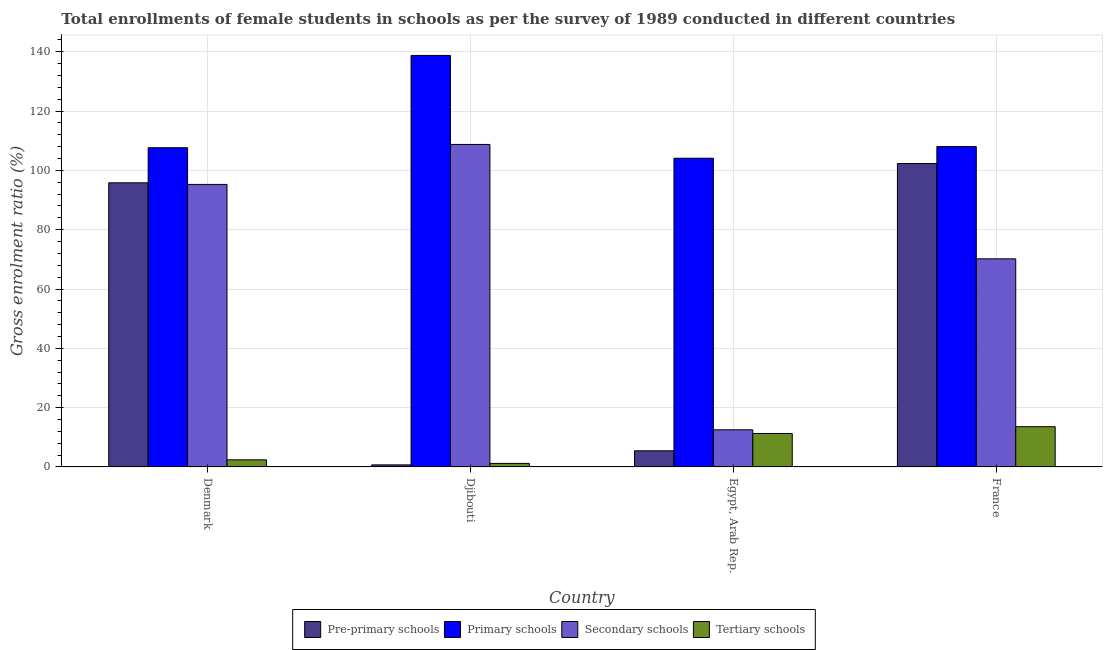Are the number of bars on each tick of the X-axis equal?
Provide a short and direct response. Yes. How many bars are there on the 2nd tick from the left?
Provide a succinct answer. 4. How many bars are there on the 1st tick from the right?
Your response must be concise. 4. What is the label of the 2nd group of bars from the left?
Offer a terse response. Djibouti. What is the gross enrolment ratio(female) in secondary schools in France?
Provide a short and direct response. 70.17. Across all countries, what is the maximum gross enrolment ratio(female) in primary schools?
Give a very brief answer. 138.76. Across all countries, what is the minimum gross enrolment ratio(female) in primary schools?
Keep it short and to the point. 104.1. In which country was the gross enrolment ratio(female) in primary schools maximum?
Your response must be concise. Djibouti. In which country was the gross enrolment ratio(female) in pre-primary schools minimum?
Provide a succinct answer. Djibouti. What is the total gross enrolment ratio(female) in secondary schools in the graph?
Give a very brief answer. 286.72. What is the difference between the gross enrolment ratio(female) in secondary schools in Egypt, Arab Rep. and that in France?
Provide a short and direct response. -57.65. What is the difference between the gross enrolment ratio(female) in tertiary schools in Egypt, Arab Rep. and the gross enrolment ratio(female) in secondary schools in France?
Provide a succinct answer. -58.89. What is the average gross enrolment ratio(female) in pre-primary schools per country?
Provide a short and direct response. 51.06. What is the difference between the gross enrolment ratio(female) in pre-primary schools and gross enrolment ratio(female) in secondary schools in France?
Provide a short and direct response. 32.14. In how many countries, is the gross enrolment ratio(female) in primary schools greater than 32 %?
Provide a succinct answer. 4. What is the ratio of the gross enrolment ratio(female) in primary schools in Denmark to that in Djibouti?
Give a very brief answer. 0.78. What is the difference between the highest and the second highest gross enrolment ratio(female) in pre-primary schools?
Keep it short and to the point. 6.5. What is the difference between the highest and the lowest gross enrolment ratio(female) in tertiary schools?
Your answer should be very brief. 12.38. In how many countries, is the gross enrolment ratio(female) in tertiary schools greater than the average gross enrolment ratio(female) in tertiary schools taken over all countries?
Provide a succinct answer. 2. What does the 1st bar from the left in France represents?
Your answer should be very brief. Pre-primary schools. What does the 1st bar from the right in France represents?
Your response must be concise. Tertiary schools. How many bars are there?
Offer a terse response. 16. Are all the bars in the graph horizontal?
Provide a short and direct response. No. How many countries are there in the graph?
Keep it short and to the point. 4. Are the values on the major ticks of Y-axis written in scientific E-notation?
Give a very brief answer. No. How are the legend labels stacked?
Offer a terse response. Horizontal. What is the title of the graph?
Your response must be concise. Total enrollments of female students in schools as per the survey of 1989 conducted in different countries. Does "Salary of employees" appear as one of the legend labels in the graph?
Offer a terse response. No. What is the label or title of the X-axis?
Ensure brevity in your answer.  Country. What is the label or title of the Y-axis?
Provide a short and direct response. Gross enrolment ratio (%). What is the Gross enrolment ratio (%) of Pre-primary schools in Denmark?
Offer a terse response. 95.81. What is the Gross enrolment ratio (%) in Primary schools in Denmark?
Give a very brief answer. 107.64. What is the Gross enrolment ratio (%) in Secondary schools in Denmark?
Your answer should be very brief. 95.27. What is the Gross enrolment ratio (%) in Tertiary schools in Denmark?
Your response must be concise. 2.39. What is the Gross enrolment ratio (%) in Pre-primary schools in Djibouti?
Provide a succinct answer. 0.69. What is the Gross enrolment ratio (%) of Primary schools in Djibouti?
Provide a short and direct response. 138.76. What is the Gross enrolment ratio (%) of Secondary schools in Djibouti?
Your answer should be compact. 108.75. What is the Gross enrolment ratio (%) of Tertiary schools in Djibouti?
Ensure brevity in your answer.  1.19. What is the Gross enrolment ratio (%) in Pre-primary schools in Egypt, Arab Rep.?
Offer a very short reply. 5.44. What is the Gross enrolment ratio (%) of Primary schools in Egypt, Arab Rep.?
Offer a terse response. 104.1. What is the Gross enrolment ratio (%) of Secondary schools in Egypt, Arab Rep.?
Your answer should be very brief. 12.52. What is the Gross enrolment ratio (%) in Tertiary schools in Egypt, Arab Rep.?
Offer a terse response. 11.28. What is the Gross enrolment ratio (%) of Pre-primary schools in France?
Offer a very short reply. 102.31. What is the Gross enrolment ratio (%) in Primary schools in France?
Make the answer very short. 108.03. What is the Gross enrolment ratio (%) of Secondary schools in France?
Your answer should be very brief. 70.17. What is the Gross enrolment ratio (%) in Tertiary schools in France?
Give a very brief answer. 13.57. Across all countries, what is the maximum Gross enrolment ratio (%) of Pre-primary schools?
Provide a short and direct response. 102.31. Across all countries, what is the maximum Gross enrolment ratio (%) in Primary schools?
Make the answer very short. 138.76. Across all countries, what is the maximum Gross enrolment ratio (%) of Secondary schools?
Provide a succinct answer. 108.75. Across all countries, what is the maximum Gross enrolment ratio (%) of Tertiary schools?
Offer a very short reply. 13.57. Across all countries, what is the minimum Gross enrolment ratio (%) in Pre-primary schools?
Your response must be concise. 0.69. Across all countries, what is the minimum Gross enrolment ratio (%) of Primary schools?
Provide a short and direct response. 104.1. Across all countries, what is the minimum Gross enrolment ratio (%) of Secondary schools?
Your response must be concise. 12.52. Across all countries, what is the minimum Gross enrolment ratio (%) in Tertiary schools?
Provide a short and direct response. 1.19. What is the total Gross enrolment ratio (%) in Pre-primary schools in the graph?
Make the answer very short. 204.26. What is the total Gross enrolment ratio (%) of Primary schools in the graph?
Offer a very short reply. 458.53. What is the total Gross enrolment ratio (%) in Secondary schools in the graph?
Your response must be concise. 286.72. What is the total Gross enrolment ratio (%) of Tertiary schools in the graph?
Ensure brevity in your answer.  28.44. What is the difference between the Gross enrolment ratio (%) in Pre-primary schools in Denmark and that in Djibouti?
Provide a succinct answer. 95.12. What is the difference between the Gross enrolment ratio (%) in Primary schools in Denmark and that in Djibouti?
Ensure brevity in your answer.  -31.12. What is the difference between the Gross enrolment ratio (%) of Secondary schools in Denmark and that in Djibouti?
Offer a terse response. -13.48. What is the difference between the Gross enrolment ratio (%) in Tertiary schools in Denmark and that in Djibouti?
Give a very brief answer. 1.2. What is the difference between the Gross enrolment ratio (%) of Pre-primary schools in Denmark and that in Egypt, Arab Rep.?
Keep it short and to the point. 90.37. What is the difference between the Gross enrolment ratio (%) of Primary schools in Denmark and that in Egypt, Arab Rep.?
Keep it short and to the point. 3.54. What is the difference between the Gross enrolment ratio (%) of Secondary schools in Denmark and that in Egypt, Arab Rep.?
Offer a very short reply. 82.75. What is the difference between the Gross enrolment ratio (%) of Tertiary schools in Denmark and that in Egypt, Arab Rep.?
Ensure brevity in your answer.  -8.89. What is the difference between the Gross enrolment ratio (%) in Pre-primary schools in Denmark and that in France?
Keep it short and to the point. -6.5. What is the difference between the Gross enrolment ratio (%) in Primary schools in Denmark and that in France?
Offer a terse response. -0.39. What is the difference between the Gross enrolment ratio (%) in Secondary schools in Denmark and that in France?
Make the answer very short. 25.1. What is the difference between the Gross enrolment ratio (%) of Tertiary schools in Denmark and that in France?
Offer a very short reply. -11.18. What is the difference between the Gross enrolment ratio (%) in Pre-primary schools in Djibouti and that in Egypt, Arab Rep.?
Ensure brevity in your answer.  -4.75. What is the difference between the Gross enrolment ratio (%) of Primary schools in Djibouti and that in Egypt, Arab Rep.?
Give a very brief answer. 34.66. What is the difference between the Gross enrolment ratio (%) in Secondary schools in Djibouti and that in Egypt, Arab Rep.?
Make the answer very short. 96.23. What is the difference between the Gross enrolment ratio (%) in Tertiary schools in Djibouti and that in Egypt, Arab Rep.?
Provide a succinct answer. -10.09. What is the difference between the Gross enrolment ratio (%) of Pre-primary schools in Djibouti and that in France?
Make the answer very short. -101.62. What is the difference between the Gross enrolment ratio (%) in Primary schools in Djibouti and that in France?
Your answer should be very brief. 30.73. What is the difference between the Gross enrolment ratio (%) of Secondary schools in Djibouti and that in France?
Your answer should be compact. 38.58. What is the difference between the Gross enrolment ratio (%) in Tertiary schools in Djibouti and that in France?
Ensure brevity in your answer.  -12.38. What is the difference between the Gross enrolment ratio (%) of Pre-primary schools in Egypt, Arab Rep. and that in France?
Offer a very short reply. -96.87. What is the difference between the Gross enrolment ratio (%) of Primary schools in Egypt, Arab Rep. and that in France?
Give a very brief answer. -3.93. What is the difference between the Gross enrolment ratio (%) of Secondary schools in Egypt, Arab Rep. and that in France?
Keep it short and to the point. -57.65. What is the difference between the Gross enrolment ratio (%) in Tertiary schools in Egypt, Arab Rep. and that in France?
Your response must be concise. -2.29. What is the difference between the Gross enrolment ratio (%) of Pre-primary schools in Denmark and the Gross enrolment ratio (%) of Primary schools in Djibouti?
Your answer should be compact. -42.95. What is the difference between the Gross enrolment ratio (%) in Pre-primary schools in Denmark and the Gross enrolment ratio (%) in Secondary schools in Djibouti?
Provide a succinct answer. -12.94. What is the difference between the Gross enrolment ratio (%) of Pre-primary schools in Denmark and the Gross enrolment ratio (%) of Tertiary schools in Djibouti?
Offer a very short reply. 94.62. What is the difference between the Gross enrolment ratio (%) in Primary schools in Denmark and the Gross enrolment ratio (%) in Secondary schools in Djibouti?
Offer a terse response. -1.11. What is the difference between the Gross enrolment ratio (%) in Primary schools in Denmark and the Gross enrolment ratio (%) in Tertiary schools in Djibouti?
Your answer should be compact. 106.45. What is the difference between the Gross enrolment ratio (%) of Secondary schools in Denmark and the Gross enrolment ratio (%) of Tertiary schools in Djibouti?
Offer a terse response. 94.08. What is the difference between the Gross enrolment ratio (%) of Pre-primary schools in Denmark and the Gross enrolment ratio (%) of Primary schools in Egypt, Arab Rep.?
Provide a short and direct response. -8.29. What is the difference between the Gross enrolment ratio (%) of Pre-primary schools in Denmark and the Gross enrolment ratio (%) of Secondary schools in Egypt, Arab Rep.?
Provide a succinct answer. 83.29. What is the difference between the Gross enrolment ratio (%) in Pre-primary schools in Denmark and the Gross enrolment ratio (%) in Tertiary schools in Egypt, Arab Rep.?
Make the answer very short. 84.53. What is the difference between the Gross enrolment ratio (%) in Primary schools in Denmark and the Gross enrolment ratio (%) in Secondary schools in Egypt, Arab Rep.?
Your response must be concise. 95.12. What is the difference between the Gross enrolment ratio (%) of Primary schools in Denmark and the Gross enrolment ratio (%) of Tertiary schools in Egypt, Arab Rep.?
Provide a succinct answer. 96.36. What is the difference between the Gross enrolment ratio (%) of Secondary schools in Denmark and the Gross enrolment ratio (%) of Tertiary schools in Egypt, Arab Rep.?
Offer a terse response. 83.99. What is the difference between the Gross enrolment ratio (%) in Pre-primary schools in Denmark and the Gross enrolment ratio (%) in Primary schools in France?
Your response must be concise. -12.22. What is the difference between the Gross enrolment ratio (%) in Pre-primary schools in Denmark and the Gross enrolment ratio (%) in Secondary schools in France?
Your answer should be compact. 25.64. What is the difference between the Gross enrolment ratio (%) in Pre-primary schools in Denmark and the Gross enrolment ratio (%) in Tertiary schools in France?
Give a very brief answer. 82.24. What is the difference between the Gross enrolment ratio (%) of Primary schools in Denmark and the Gross enrolment ratio (%) of Secondary schools in France?
Make the answer very short. 37.47. What is the difference between the Gross enrolment ratio (%) in Primary schools in Denmark and the Gross enrolment ratio (%) in Tertiary schools in France?
Offer a very short reply. 94.07. What is the difference between the Gross enrolment ratio (%) of Secondary schools in Denmark and the Gross enrolment ratio (%) of Tertiary schools in France?
Ensure brevity in your answer.  81.7. What is the difference between the Gross enrolment ratio (%) in Pre-primary schools in Djibouti and the Gross enrolment ratio (%) in Primary schools in Egypt, Arab Rep.?
Make the answer very short. -103.41. What is the difference between the Gross enrolment ratio (%) of Pre-primary schools in Djibouti and the Gross enrolment ratio (%) of Secondary schools in Egypt, Arab Rep.?
Make the answer very short. -11.83. What is the difference between the Gross enrolment ratio (%) of Pre-primary schools in Djibouti and the Gross enrolment ratio (%) of Tertiary schools in Egypt, Arab Rep.?
Make the answer very short. -10.59. What is the difference between the Gross enrolment ratio (%) in Primary schools in Djibouti and the Gross enrolment ratio (%) in Secondary schools in Egypt, Arab Rep.?
Ensure brevity in your answer.  126.24. What is the difference between the Gross enrolment ratio (%) of Primary schools in Djibouti and the Gross enrolment ratio (%) of Tertiary schools in Egypt, Arab Rep.?
Provide a short and direct response. 127.48. What is the difference between the Gross enrolment ratio (%) in Secondary schools in Djibouti and the Gross enrolment ratio (%) in Tertiary schools in Egypt, Arab Rep.?
Offer a terse response. 97.47. What is the difference between the Gross enrolment ratio (%) of Pre-primary schools in Djibouti and the Gross enrolment ratio (%) of Primary schools in France?
Your answer should be compact. -107.34. What is the difference between the Gross enrolment ratio (%) of Pre-primary schools in Djibouti and the Gross enrolment ratio (%) of Secondary schools in France?
Offer a very short reply. -69.48. What is the difference between the Gross enrolment ratio (%) in Pre-primary schools in Djibouti and the Gross enrolment ratio (%) in Tertiary schools in France?
Ensure brevity in your answer.  -12.88. What is the difference between the Gross enrolment ratio (%) in Primary schools in Djibouti and the Gross enrolment ratio (%) in Secondary schools in France?
Your answer should be very brief. 68.59. What is the difference between the Gross enrolment ratio (%) of Primary schools in Djibouti and the Gross enrolment ratio (%) of Tertiary schools in France?
Keep it short and to the point. 125.19. What is the difference between the Gross enrolment ratio (%) of Secondary schools in Djibouti and the Gross enrolment ratio (%) of Tertiary schools in France?
Give a very brief answer. 95.18. What is the difference between the Gross enrolment ratio (%) of Pre-primary schools in Egypt, Arab Rep. and the Gross enrolment ratio (%) of Primary schools in France?
Ensure brevity in your answer.  -102.59. What is the difference between the Gross enrolment ratio (%) of Pre-primary schools in Egypt, Arab Rep. and the Gross enrolment ratio (%) of Secondary schools in France?
Make the answer very short. -64.73. What is the difference between the Gross enrolment ratio (%) in Pre-primary schools in Egypt, Arab Rep. and the Gross enrolment ratio (%) in Tertiary schools in France?
Ensure brevity in your answer.  -8.13. What is the difference between the Gross enrolment ratio (%) of Primary schools in Egypt, Arab Rep. and the Gross enrolment ratio (%) of Secondary schools in France?
Provide a short and direct response. 33.93. What is the difference between the Gross enrolment ratio (%) in Primary schools in Egypt, Arab Rep. and the Gross enrolment ratio (%) in Tertiary schools in France?
Make the answer very short. 90.53. What is the difference between the Gross enrolment ratio (%) in Secondary schools in Egypt, Arab Rep. and the Gross enrolment ratio (%) in Tertiary schools in France?
Your answer should be compact. -1.05. What is the average Gross enrolment ratio (%) in Pre-primary schools per country?
Provide a succinct answer. 51.06. What is the average Gross enrolment ratio (%) in Primary schools per country?
Provide a short and direct response. 114.63. What is the average Gross enrolment ratio (%) in Secondary schools per country?
Provide a short and direct response. 71.68. What is the average Gross enrolment ratio (%) in Tertiary schools per country?
Offer a terse response. 7.11. What is the difference between the Gross enrolment ratio (%) in Pre-primary schools and Gross enrolment ratio (%) in Primary schools in Denmark?
Keep it short and to the point. -11.83. What is the difference between the Gross enrolment ratio (%) of Pre-primary schools and Gross enrolment ratio (%) of Secondary schools in Denmark?
Provide a succinct answer. 0.54. What is the difference between the Gross enrolment ratio (%) in Pre-primary schools and Gross enrolment ratio (%) in Tertiary schools in Denmark?
Offer a very short reply. 93.42. What is the difference between the Gross enrolment ratio (%) of Primary schools and Gross enrolment ratio (%) of Secondary schools in Denmark?
Offer a very short reply. 12.37. What is the difference between the Gross enrolment ratio (%) in Primary schools and Gross enrolment ratio (%) in Tertiary schools in Denmark?
Your answer should be very brief. 105.24. What is the difference between the Gross enrolment ratio (%) in Secondary schools and Gross enrolment ratio (%) in Tertiary schools in Denmark?
Provide a short and direct response. 92.88. What is the difference between the Gross enrolment ratio (%) of Pre-primary schools and Gross enrolment ratio (%) of Primary schools in Djibouti?
Provide a short and direct response. -138.07. What is the difference between the Gross enrolment ratio (%) of Pre-primary schools and Gross enrolment ratio (%) of Secondary schools in Djibouti?
Your response must be concise. -108.06. What is the difference between the Gross enrolment ratio (%) of Pre-primary schools and Gross enrolment ratio (%) of Tertiary schools in Djibouti?
Give a very brief answer. -0.5. What is the difference between the Gross enrolment ratio (%) of Primary schools and Gross enrolment ratio (%) of Secondary schools in Djibouti?
Provide a succinct answer. 30.01. What is the difference between the Gross enrolment ratio (%) of Primary schools and Gross enrolment ratio (%) of Tertiary schools in Djibouti?
Ensure brevity in your answer.  137.57. What is the difference between the Gross enrolment ratio (%) in Secondary schools and Gross enrolment ratio (%) in Tertiary schools in Djibouti?
Your answer should be compact. 107.56. What is the difference between the Gross enrolment ratio (%) in Pre-primary schools and Gross enrolment ratio (%) in Primary schools in Egypt, Arab Rep.?
Provide a succinct answer. -98.66. What is the difference between the Gross enrolment ratio (%) of Pre-primary schools and Gross enrolment ratio (%) of Secondary schools in Egypt, Arab Rep.?
Your answer should be very brief. -7.08. What is the difference between the Gross enrolment ratio (%) of Pre-primary schools and Gross enrolment ratio (%) of Tertiary schools in Egypt, Arab Rep.?
Make the answer very short. -5.84. What is the difference between the Gross enrolment ratio (%) of Primary schools and Gross enrolment ratio (%) of Secondary schools in Egypt, Arab Rep.?
Your answer should be very brief. 91.58. What is the difference between the Gross enrolment ratio (%) in Primary schools and Gross enrolment ratio (%) in Tertiary schools in Egypt, Arab Rep.?
Your answer should be very brief. 92.82. What is the difference between the Gross enrolment ratio (%) in Secondary schools and Gross enrolment ratio (%) in Tertiary schools in Egypt, Arab Rep.?
Your response must be concise. 1.24. What is the difference between the Gross enrolment ratio (%) of Pre-primary schools and Gross enrolment ratio (%) of Primary schools in France?
Ensure brevity in your answer.  -5.72. What is the difference between the Gross enrolment ratio (%) in Pre-primary schools and Gross enrolment ratio (%) in Secondary schools in France?
Your answer should be compact. 32.14. What is the difference between the Gross enrolment ratio (%) of Pre-primary schools and Gross enrolment ratio (%) of Tertiary schools in France?
Provide a succinct answer. 88.74. What is the difference between the Gross enrolment ratio (%) in Primary schools and Gross enrolment ratio (%) in Secondary schools in France?
Your answer should be very brief. 37.86. What is the difference between the Gross enrolment ratio (%) in Primary schools and Gross enrolment ratio (%) in Tertiary schools in France?
Offer a very short reply. 94.46. What is the difference between the Gross enrolment ratio (%) in Secondary schools and Gross enrolment ratio (%) in Tertiary schools in France?
Your response must be concise. 56.6. What is the ratio of the Gross enrolment ratio (%) in Pre-primary schools in Denmark to that in Djibouti?
Provide a short and direct response. 138.33. What is the ratio of the Gross enrolment ratio (%) of Primary schools in Denmark to that in Djibouti?
Provide a succinct answer. 0.78. What is the ratio of the Gross enrolment ratio (%) in Secondary schools in Denmark to that in Djibouti?
Provide a succinct answer. 0.88. What is the ratio of the Gross enrolment ratio (%) in Tertiary schools in Denmark to that in Djibouti?
Give a very brief answer. 2.01. What is the ratio of the Gross enrolment ratio (%) of Pre-primary schools in Denmark to that in Egypt, Arab Rep.?
Make the answer very short. 17.61. What is the ratio of the Gross enrolment ratio (%) in Primary schools in Denmark to that in Egypt, Arab Rep.?
Keep it short and to the point. 1.03. What is the ratio of the Gross enrolment ratio (%) in Secondary schools in Denmark to that in Egypt, Arab Rep.?
Your answer should be compact. 7.61. What is the ratio of the Gross enrolment ratio (%) in Tertiary schools in Denmark to that in Egypt, Arab Rep.?
Your answer should be compact. 0.21. What is the ratio of the Gross enrolment ratio (%) of Pre-primary schools in Denmark to that in France?
Your response must be concise. 0.94. What is the ratio of the Gross enrolment ratio (%) of Primary schools in Denmark to that in France?
Ensure brevity in your answer.  1. What is the ratio of the Gross enrolment ratio (%) of Secondary schools in Denmark to that in France?
Provide a succinct answer. 1.36. What is the ratio of the Gross enrolment ratio (%) in Tertiary schools in Denmark to that in France?
Provide a succinct answer. 0.18. What is the ratio of the Gross enrolment ratio (%) in Pre-primary schools in Djibouti to that in Egypt, Arab Rep.?
Make the answer very short. 0.13. What is the ratio of the Gross enrolment ratio (%) in Primary schools in Djibouti to that in Egypt, Arab Rep.?
Your answer should be very brief. 1.33. What is the ratio of the Gross enrolment ratio (%) of Secondary schools in Djibouti to that in Egypt, Arab Rep.?
Offer a terse response. 8.69. What is the ratio of the Gross enrolment ratio (%) in Tertiary schools in Djibouti to that in Egypt, Arab Rep.?
Make the answer very short. 0.11. What is the ratio of the Gross enrolment ratio (%) in Pre-primary schools in Djibouti to that in France?
Keep it short and to the point. 0.01. What is the ratio of the Gross enrolment ratio (%) in Primary schools in Djibouti to that in France?
Offer a terse response. 1.28. What is the ratio of the Gross enrolment ratio (%) of Secondary schools in Djibouti to that in France?
Make the answer very short. 1.55. What is the ratio of the Gross enrolment ratio (%) of Tertiary schools in Djibouti to that in France?
Your answer should be compact. 0.09. What is the ratio of the Gross enrolment ratio (%) of Pre-primary schools in Egypt, Arab Rep. to that in France?
Your answer should be compact. 0.05. What is the ratio of the Gross enrolment ratio (%) in Primary schools in Egypt, Arab Rep. to that in France?
Your response must be concise. 0.96. What is the ratio of the Gross enrolment ratio (%) in Secondary schools in Egypt, Arab Rep. to that in France?
Provide a succinct answer. 0.18. What is the ratio of the Gross enrolment ratio (%) of Tertiary schools in Egypt, Arab Rep. to that in France?
Your response must be concise. 0.83. What is the difference between the highest and the second highest Gross enrolment ratio (%) in Pre-primary schools?
Provide a succinct answer. 6.5. What is the difference between the highest and the second highest Gross enrolment ratio (%) in Primary schools?
Provide a succinct answer. 30.73. What is the difference between the highest and the second highest Gross enrolment ratio (%) of Secondary schools?
Offer a very short reply. 13.48. What is the difference between the highest and the second highest Gross enrolment ratio (%) in Tertiary schools?
Your response must be concise. 2.29. What is the difference between the highest and the lowest Gross enrolment ratio (%) in Pre-primary schools?
Offer a very short reply. 101.62. What is the difference between the highest and the lowest Gross enrolment ratio (%) in Primary schools?
Keep it short and to the point. 34.66. What is the difference between the highest and the lowest Gross enrolment ratio (%) of Secondary schools?
Offer a terse response. 96.23. What is the difference between the highest and the lowest Gross enrolment ratio (%) in Tertiary schools?
Keep it short and to the point. 12.38. 